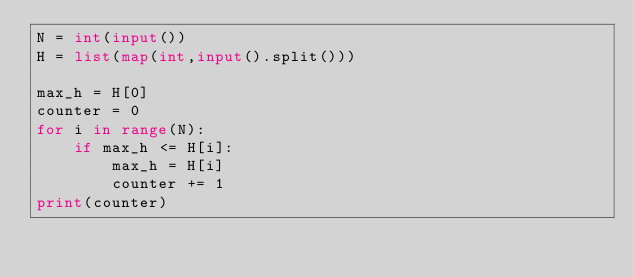<code> <loc_0><loc_0><loc_500><loc_500><_Python_>N = int(input())
H = list(map(int,input().split()))

max_h = H[0]
counter = 0
for i in range(N):
    if max_h <= H[i]:
        max_h = H[i]
        counter += 1
print(counter)</code> 